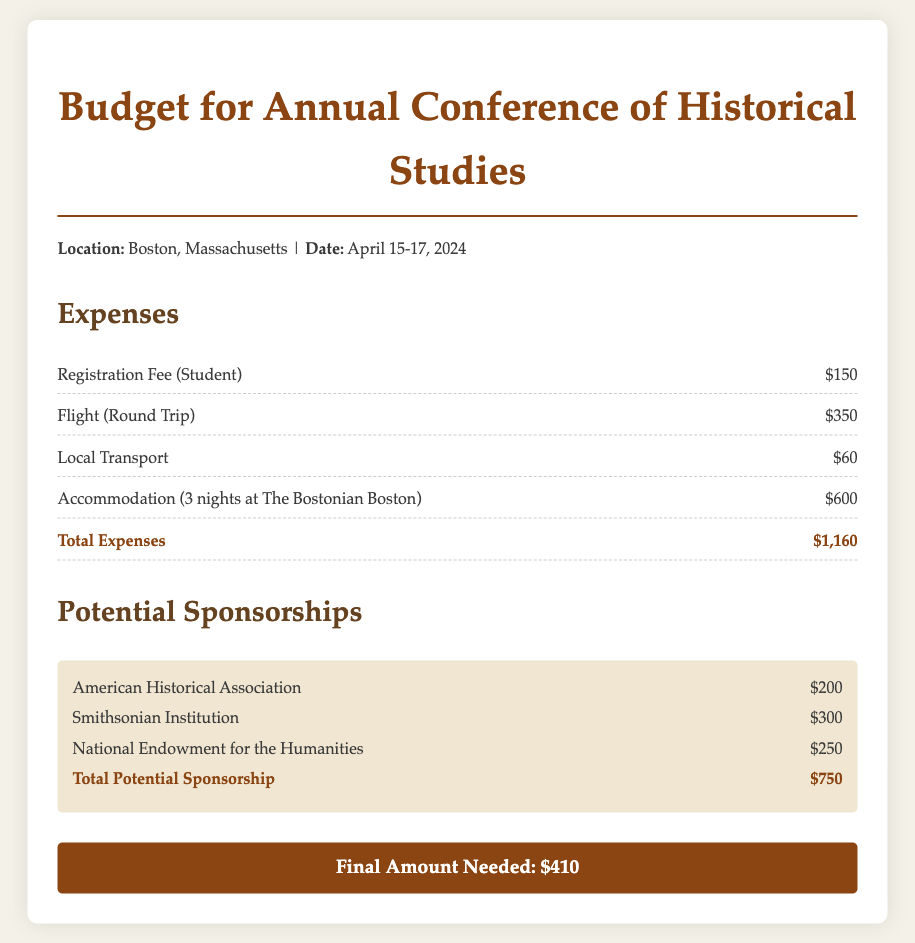What is the registration fee for a student? The registration fee for a student is clearly stated in the document as $150.
Answer: $150 What is the flight cost for a round trip? The document specifies that the flight (round trip) costs $350.
Answer: $350 What is the total amount of potential sponsorship? The total potential sponsorship is given in the document as $750, which is the sum of all listed sponsorships.
Answer: $750 How many nights is accommodation booked for? The document notes that accommodation is booked for 3 nights.
Answer: 3 nights What is the total expense listed in the budget? The total expenses, which include all costs, are summed up to $1,160 in the document.
Answer: $1,160 What is the final amount needed after accounting for sponsorships? The final amount needed after accounting for sponsorships is provided as $410.
Answer: $410 Which hotel is mentioned for accommodation? The document mentions The Bostonian Boston for accommodation during the conference.
Answer: The Bostonian Boston Which organization is listed as providing $300 sponsorship? According to the document, the Smithsonian Institution is listed as providing $300 sponsorship.
Answer: Smithsonian Institution What is the local transport cost? The cost for local transport is specified as $60 in the budget.
Answer: $60 